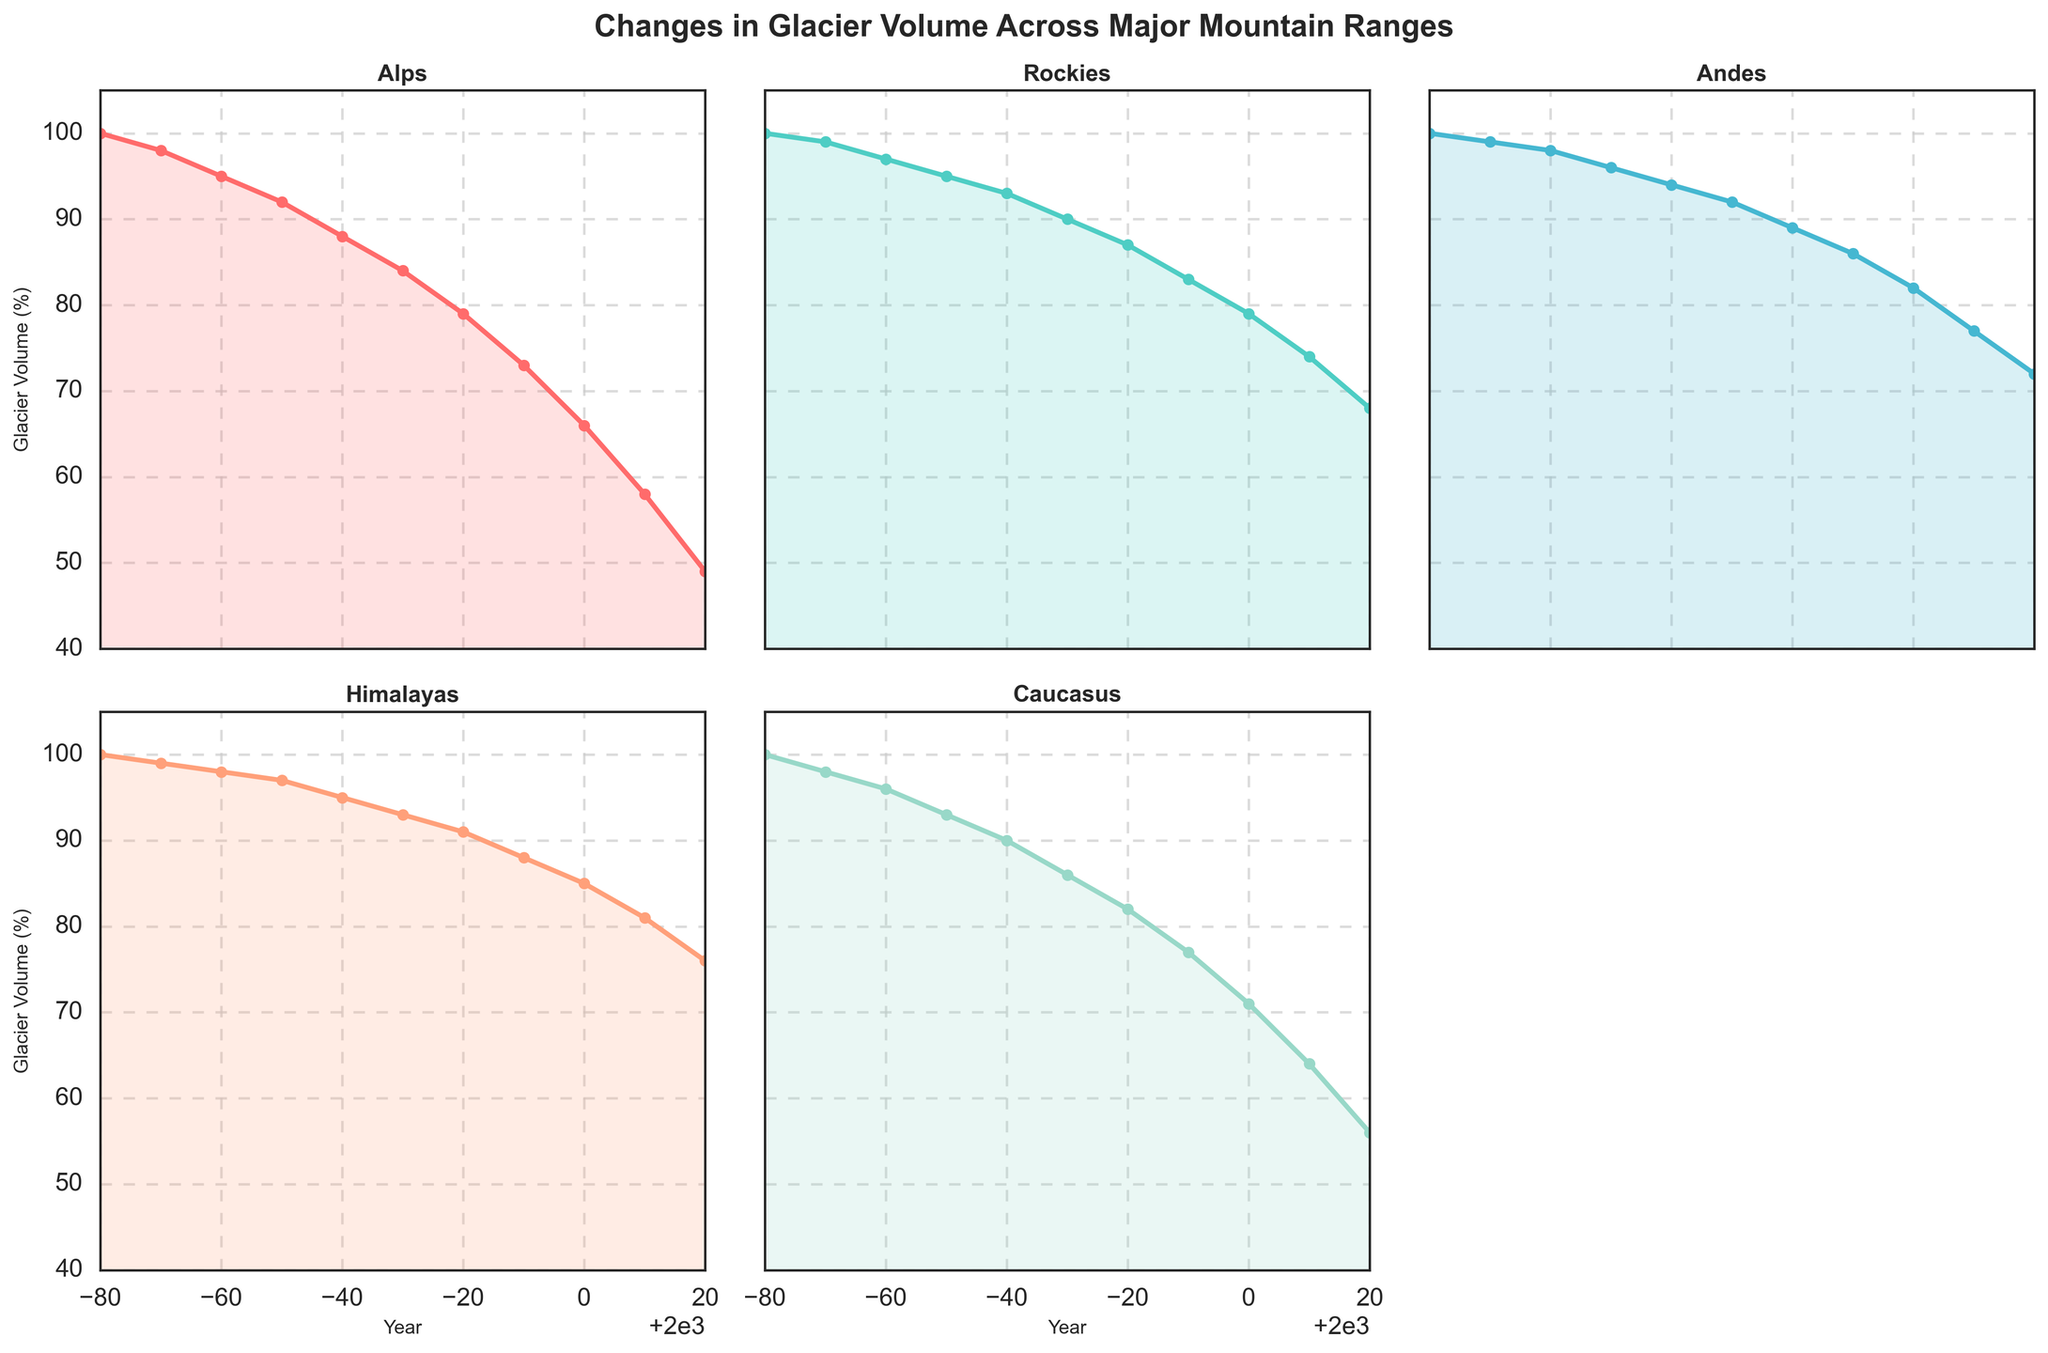What year did the glacial volume in the Alps first drop below 60%? Look at the subplot for the Alps, find the year when the glacier volume first went below 60%. This happens between 2000 and 2010, as the volume was 58% in 2010.
Answer: 2010 Which mountain range shows the steepest decline in glacier volume between 1960 and 1970? Compare the slopes of the lines in the plots for all mountain ranges between 1960 and 1970. The Alps show the steepest decline, dropping from 88% to 84%, a difference of 4%.
Answer: Alps How do the glacier volumes in the Andes and Himalayas compare in the year 2000? Refer to the plots for the Andes and Himalayas for the year 2000. The Andes had a volume of 82% and the Himalayas had a volume of 85%.
Answer: Himalayas are higher By what percentage did the glacier volume in the Rockies decrease from 1930 to 2020? Subtract the 2020 volume in the Rockies from the 1930 volume. 99% (1930) - 68% (2020) = 31%.
Answer: 31% What is the average glacier volume across all mountain ranges in the year 1990? Sum the glacier volumes for all ranges in 1990 and divide by the number of ranges: (73 + 83 + 86 + 88 + 77) / 5 = 81.4%.
Answer: 81.4% Which mountain range experienced the smallest percentage decline in glacier volume from 1920 to 2020? Calculate the percentage decline for each range: Alps (51%), Rockies (32%), Andes (28%), Himalayas (24%), Caucasus (44%). The Himalayas show the smallest decline.
Answer: Himalayas Is there any year where the glacier volumes in both the Rockies and Andes intersect? Look for a year when the volumes in the Rockies and Andes are the same. They do not intersect in any year based on the data.
Answer: No How has the trend of glacier volume in the Caucasus changed from 1980 to 2020? Examine the plot for the Caucasus. The volume steadily declines from 82% in 1980 to 56% in 2020.
Answer: Steady decline 